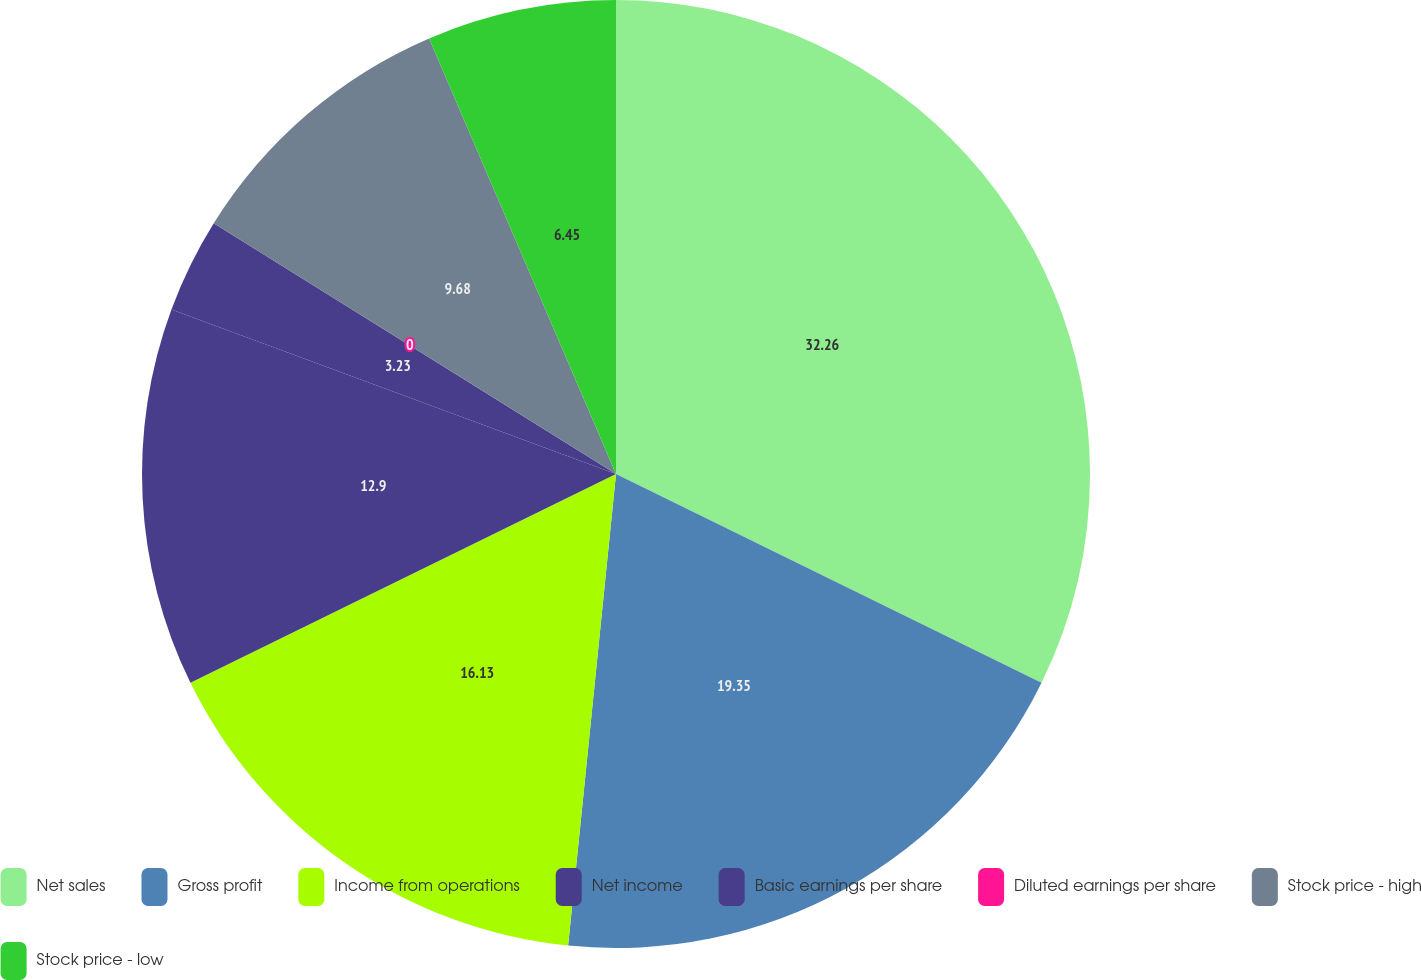Convert chart to OTSL. <chart><loc_0><loc_0><loc_500><loc_500><pie_chart><fcel>Net sales<fcel>Gross profit<fcel>Income from operations<fcel>Net income<fcel>Basic earnings per share<fcel>Diluted earnings per share<fcel>Stock price - high<fcel>Stock price - low<nl><fcel>32.26%<fcel>19.35%<fcel>16.13%<fcel>12.9%<fcel>3.23%<fcel>0.0%<fcel>9.68%<fcel>6.45%<nl></chart> 